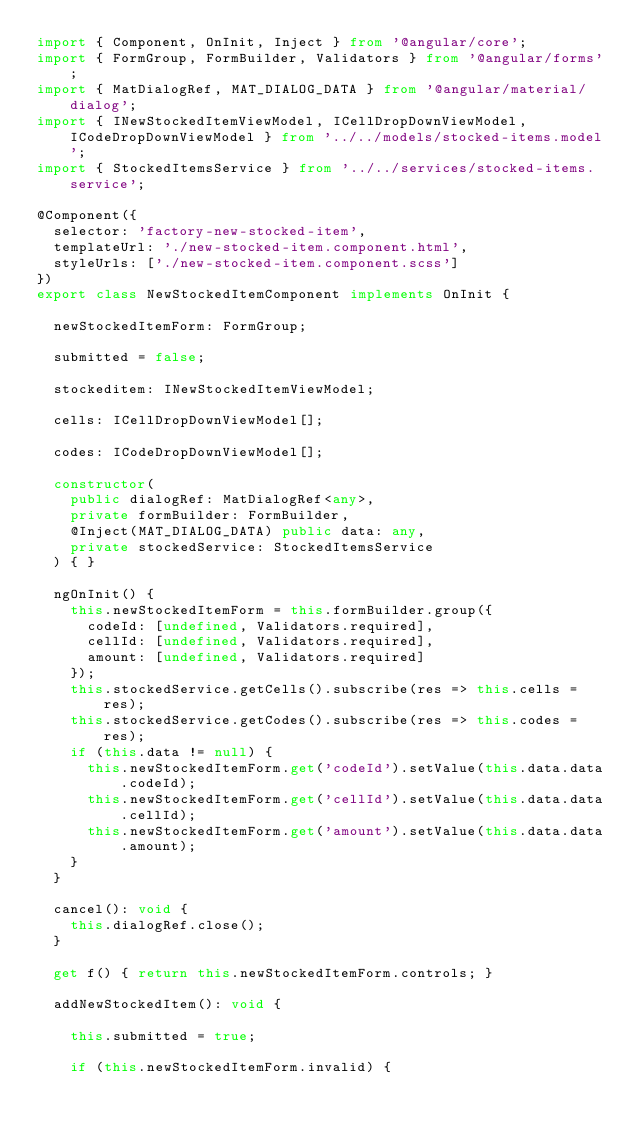<code> <loc_0><loc_0><loc_500><loc_500><_TypeScript_>import { Component, OnInit, Inject } from '@angular/core';
import { FormGroup, FormBuilder, Validators } from '@angular/forms';
import { MatDialogRef, MAT_DIALOG_DATA } from '@angular/material/dialog';
import { INewStockedItemViewModel, ICellDropDownViewModel, ICodeDropDownViewModel } from '../../models/stocked-items.model';
import { StockedItemsService } from '../../services/stocked-items.service';

@Component({
  selector: 'factory-new-stocked-item',
  templateUrl: './new-stocked-item.component.html',
  styleUrls: ['./new-stocked-item.component.scss']
})
export class NewStockedItemComponent implements OnInit {

  newStockedItemForm: FormGroup;

  submitted = false;

  stockeditem: INewStockedItemViewModel;

  cells: ICellDropDownViewModel[];

  codes: ICodeDropDownViewModel[];
  
  constructor(
    public dialogRef: MatDialogRef<any>,
    private formBuilder: FormBuilder,
    @Inject(MAT_DIALOG_DATA) public data: any,
    private stockedService: StockedItemsService
  ) { }

  ngOnInit() {
    this.newStockedItemForm = this.formBuilder.group({
      codeId: [undefined, Validators.required],
      cellId: [undefined, Validators.required],
      amount: [undefined, Validators.required]
    });
    this.stockedService.getCells().subscribe(res => this.cells = res);
    this.stockedService.getCodes().subscribe(res => this.codes = res);
    if (this.data != null) {
      this.newStockedItemForm.get('codeId').setValue(this.data.data.codeId);
      this.newStockedItemForm.get('cellId').setValue(this.data.data.cellId);
      this.newStockedItemForm.get('amount').setValue(this.data.data.amount);
    }
  }

  cancel(): void {
    this.dialogRef.close();
  }

  get f() { return this.newStockedItemForm.controls; }

  addNewStockedItem(): void {

    this.submitted = true;

    if (this.newStockedItemForm.invalid) {</code> 